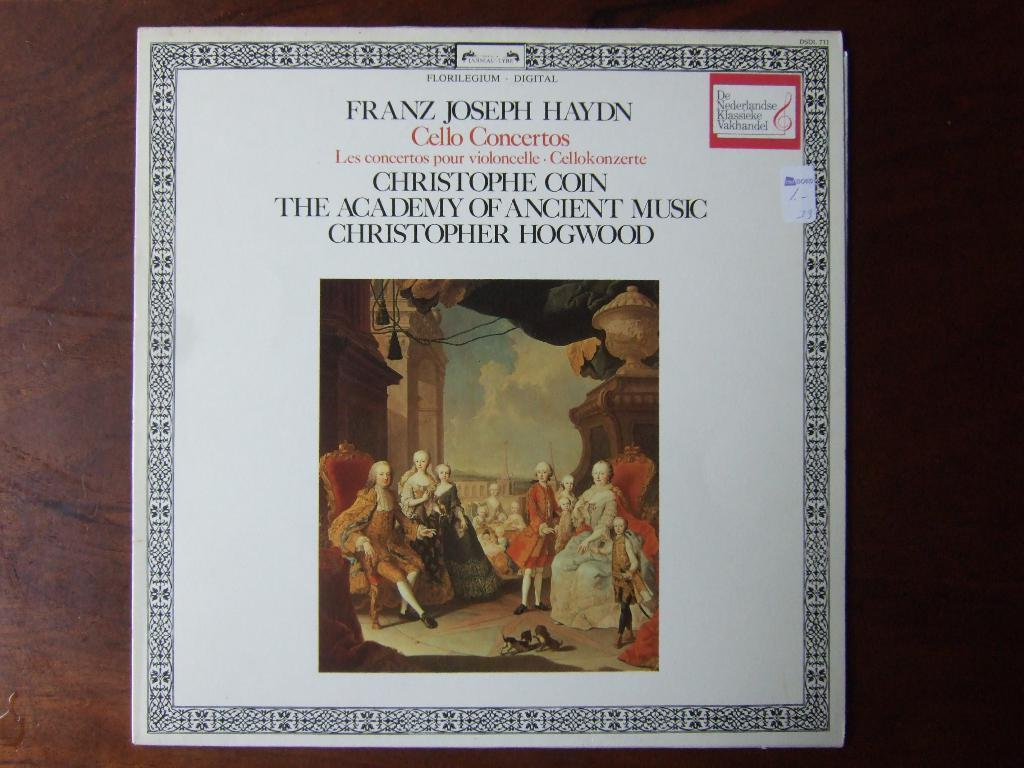<image>
Write a terse but informative summary of the picture. A picture with the name Franz Joseph Haydn at the top. 